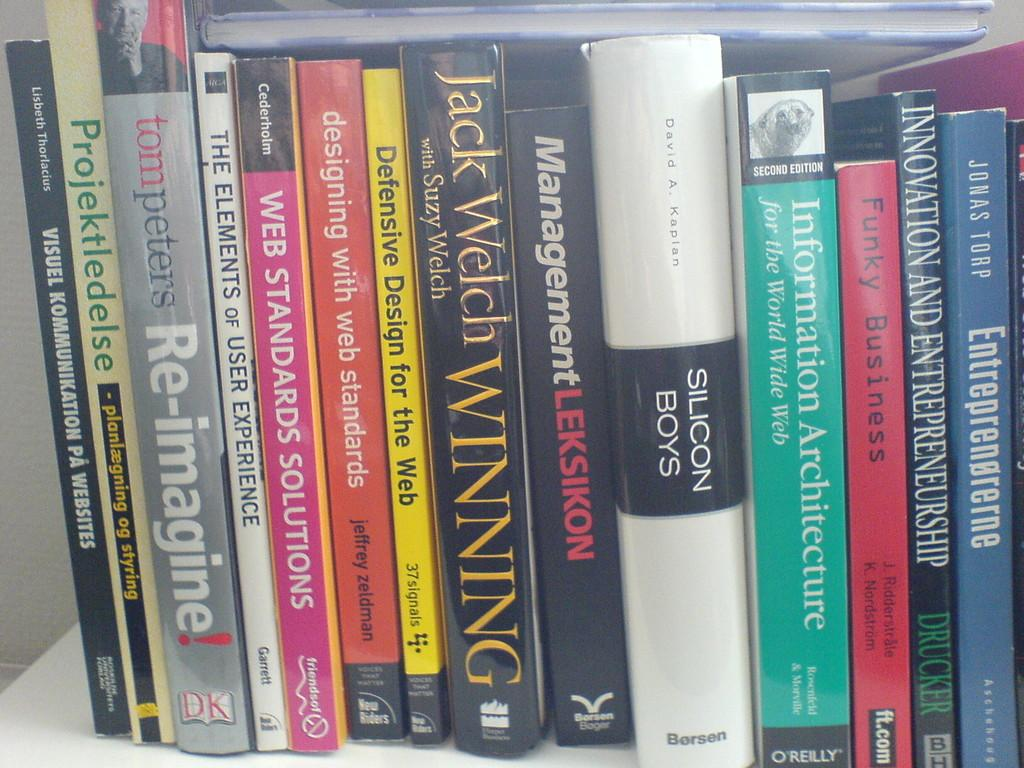Provide a one-sentence caption for the provided image. A collection of books includes many about web design. 